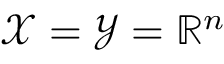Convert formula to latex. <formula><loc_0><loc_0><loc_500><loc_500>\mathcal { X } = \mathcal { Y } = \mathbb { R } ^ { n }</formula> 